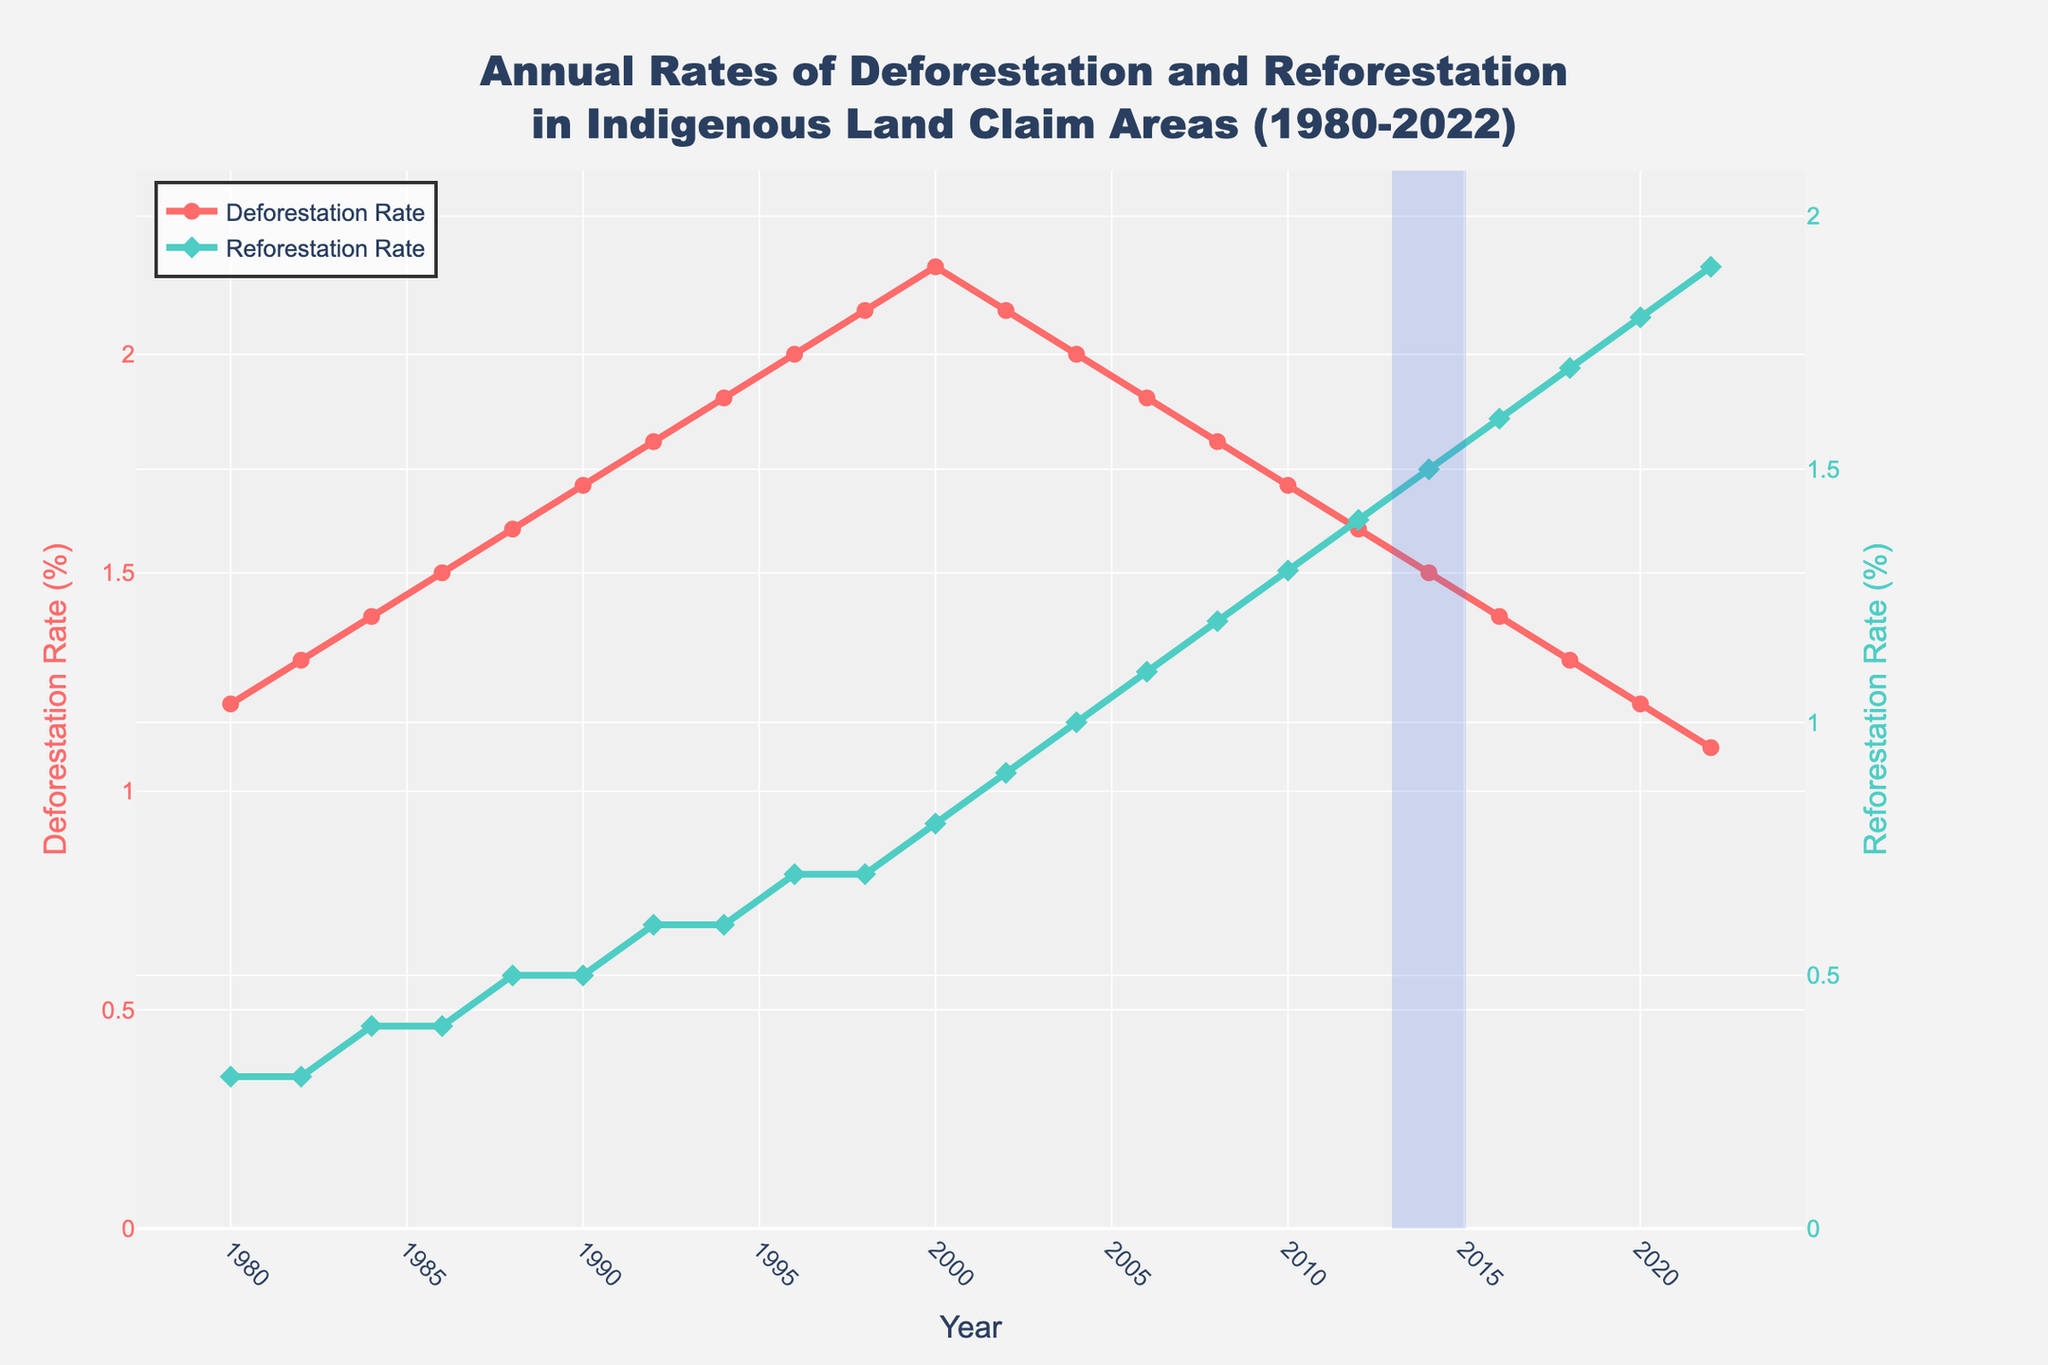What trends do Deforestation and Reforestation Rates show over the years from 1980 to 2022? Both the deforestation and reforestation rates show a trend over the years. Deforestation rates consistently increased from 1980 to approximately 2000 and then began to decrease. Reforestation rates slowly increased from 1980 and consistently continued to rise throughout the period.
Answer: Deforestation increased then decreased; Reforestation consistently increased In which year did the Reforestation Rate exceed the Deforestation Rate for the first time? The crossover point where the Reforestation Rate exceeds the Deforestation Rate can be identified by finding the highlighted section in the figure. This crossover year is clearly marked with an annotation and a shaded rectangle.
Answer: 2014 How do the Deforestation and Reforestation Rates in 2022 compare to each other? In 2022, by referring to the end of both lines in the chart, we can see that the Reforestation Rate is higher than the Deforestation Rate. Specifically, the Deforestation Rate is around 1.1% and the Reforestation Rate is around 1.9%.
Answer: Reforestation Rate is higher What general pattern can be observed about the difference between Deforestation and Reforestation Rates pre-2000 compared to post-2000? By examining the figure, it's observable that pre-2000, the Deforestation Rate was consistently higher than the Reforestation Rate. However, post-2000, the Deforestation Rate began to decrease while the Reforestation Rate increased, eventually crossing over around 2014.
Answer: Pre-2000: Deforestation > Reforestation; Post-2000: Reforestation > Deforestation What is the average Reforestation Rate from 1980 to 2000? To find the average Reforestation Rate from 1980 to 2000, sum the rates of the appropriate years and divide by the number of those years: (0.3 + 0.3 + 0.4 + 0.4 + 0.5 + 0.5 + 0.6 + 0.6 + 0.7 + 0.7 + 0.8) / 11 = 0.55%.
Answer: 0.55% During which decade did the Deforestation Rate reach its peak? By inspecting the trend in the line chart, it is evident that the peak of the Deforestation Rate occurred around the late 1990s to 2000.
Answer: 1990s How does the Deforestation Rate in 2010 compare to that in 1980? By looking at the chart, we can compare the height of the Deforestation Rate line in 2010 and 1980. The Deforestation Rate in 2010 is lower than in 1980. Specifically, it's 1.7% in 2010 and 1.2% in 1980.
Answer: Lower in 2010 How much did the Deforestation Rate decrease between 2000 and 2022? To find this, subtract the Deforestation Rate in 2022 from the rate in 2000: 2.2 - 1.1 = 1.1%.
Answer: 1.1% What visual cue indicates the significance of the year 2014 in the chart? The year 2014 is visually indicated by a shaded rectangle and an annotation marking it as the crossover point where the Reforestation Rate exceeded the Deforestation Rate.
Answer: Shaded rectangle and annotation What is the rate of increase in Reforestation Rates from 1980 to 2022? Calculate the rate of increase by subtracting the 1980 rate from the 2022 rate: 1.9 - 0.3 = 1.6%.
Answer: 1.6% 